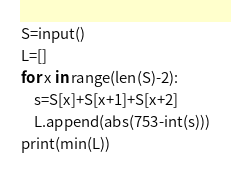Convert code to text. <code><loc_0><loc_0><loc_500><loc_500><_Python_>S=input()
L=[]
for x in range(len(S)-2):
    s=S[x]+S[x+1]+S[x+2]
    L.append(abs(753-int(s)))
print(min(L))

</code> 